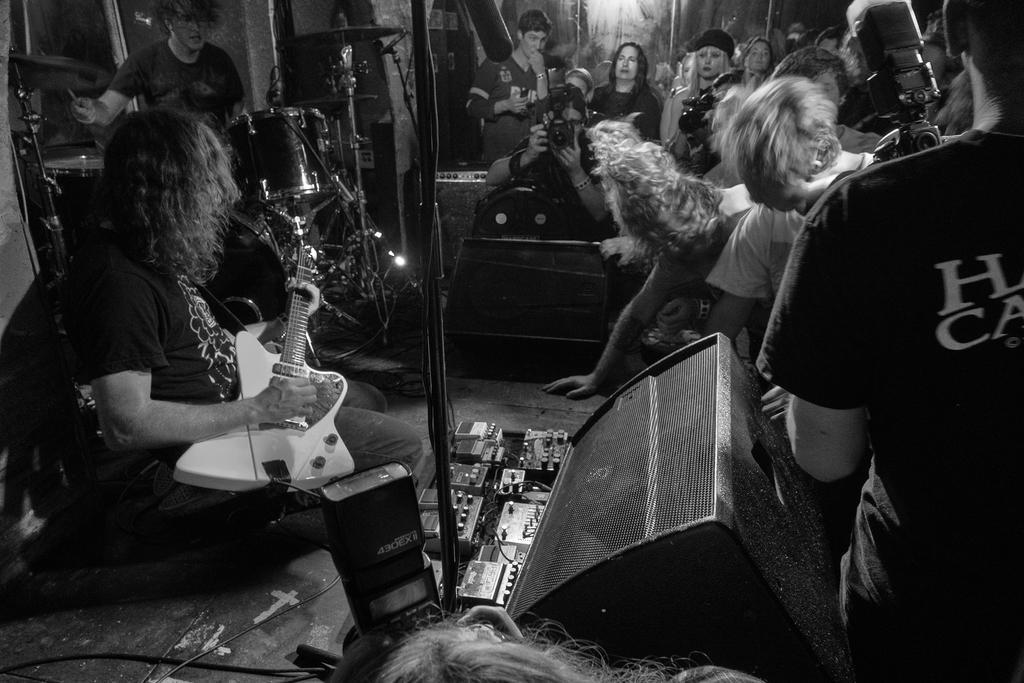Can you describe this image briefly? As we can see in the image there are few people here and there. The man who is sitting here is holding guitar and there is a musical drums over here. The man who is standing here is holding camera. 